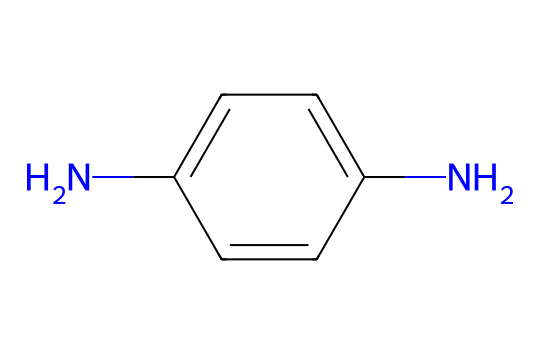What is the molecular formula of this dye? To find the molecular formula, we count the number of each type of atom present in the SMILES representation. From the structure, there are 9 carbon (C) atoms, 10 hydrogen (H) atoms, and 2 nitrogen (N) atoms. Therefore, the molecular formula is C9H10N2.
Answer: C9H10N2 How many nitrogen atoms are in the structure? By inspecting the SMILES, we count the number of nitrogen atoms represented. There are two nitrogen atoms (N) present in the structure.
Answer: 2 What type of chemical compound is this? The presence of the nitrogen atoms in an aromatic ring indicates that this compound is an aromatic amine, which is commonly used in dye formulations.
Answer: aromatic amine Does this compound contain a double bond? By examining the SMILES, we see that there are double bonds between the carbon atoms, specifically in the aromatic ring, indicating the presence of double bonds.
Answer: yes Can this dye be used for hair coloring? Given its structural elements, specifically the amino groups and aromatic ring, this compound is consistent with those found in hair dye formulations, indicating that it can be used for this purpose.
Answer: yes What kind of color does this dye typically yield? Aromatic amines like this compound often yield shades of blue or violet, depending on the specific formulation and conditions under which they are used in hair dyes.
Answer: blue or violet What is the primary functional group in this dye? The primary functional group in this compound is the amino group (–NH2), which is vital for its reactivity and ability to form dyes.
Answer: amino group 